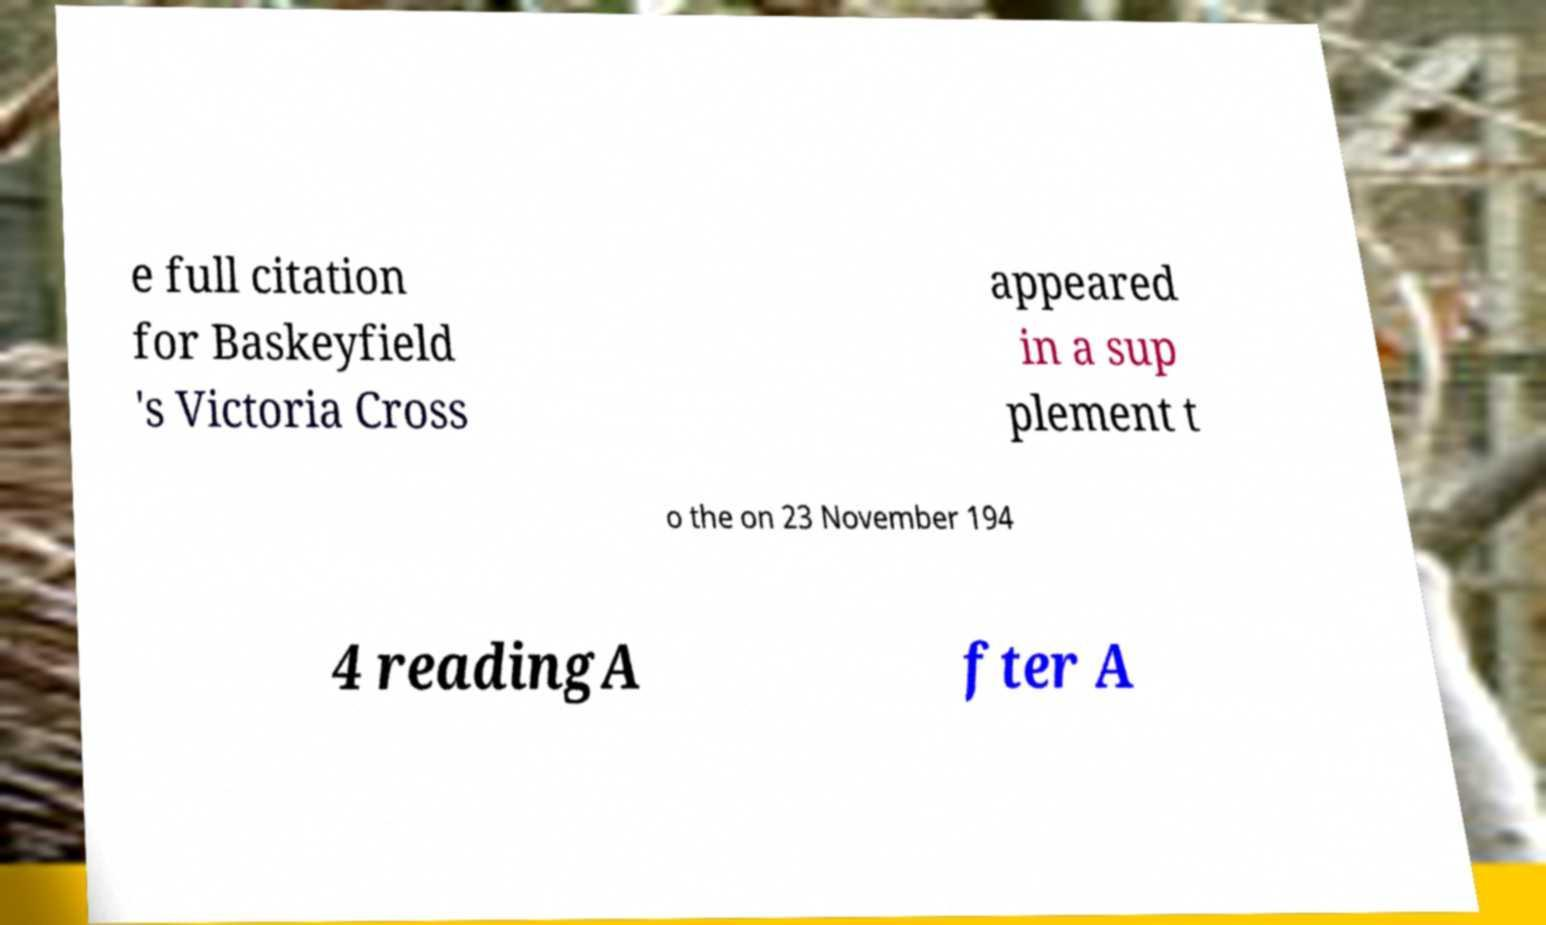Can you accurately transcribe the text from the provided image for me? e full citation for Baskeyfield 's Victoria Cross appeared in a sup plement t o the on 23 November 194 4 readingA fter A 